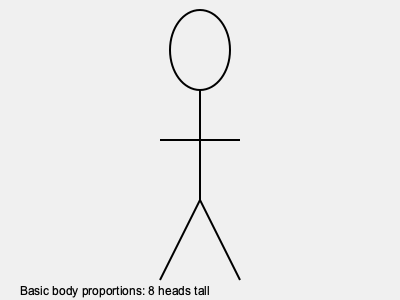In fashion illustration, what is the standard proportion used for the height of an adult figure in relation to the size of their head? To understand the standard proportion used in fashion illustration for adult figures, follow these steps:

1. Fashion illustrators use a system of proportions based on the size of the head.
2. The head is used as a unit of measurement for the entire body.
3. In classic fashion illustration, the standard adult figure is typically drawn to be 8 head units tall.
4. This means:
   - 1 head unit from the top of the head to the chin
   - 1 head unit from the chin to the middle of the chest
   - 1 head unit from the middle of the chest to the waist
   - 1 head unit from the waist to the hips
   - 2 head units from the hips to the knees
   - 2 head units from the knees to the feet
5. This 8-head proportion creates an elongated, idealized figure that is common in fashion illustration.
6. It allows for exaggeration of the legs, which is desirable in fashion design to showcase garments, particularly pants and skirts.
7. While real human proportions are closer to 7-7.5 heads tall, the 8-head proportion is an industry standard for fashion illustrations.

Understanding this proportion is crucial for creating balanced and aesthetically pleasing fashion sketches that effectively showcase designs.
Answer: 8 heads tall 